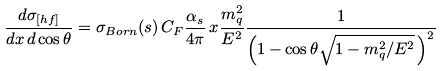<formula> <loc_0><loc_0><loc_500><loc_500>\frac { d \sigma _ { [ h f ] } } { d x \, d \cos \theta } = \sigma _ { B o r n } ( s ) \, C _ { F } \frac { \alpha _ { s } } { 4 \pi } \, x \frac { m _ { q } ^ { 2 } } { E ^ { 2 } } \frac { 1 } { \left ( 1 - \cos \theta \sqrt { 1 - m _ { q } ^ { 2 } / E ^ { 2 } } \, \right ) ^ { 2 } }</formula> 